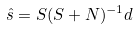<formula> <loc_0><loc_0><loc_500><loc_500>\hat { s } = S ( S + N ) ^ { - 1 } d</formula> 